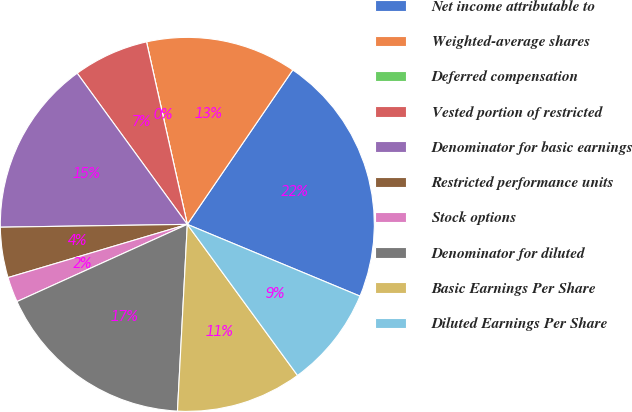Convert chart. <chart><loc_0><loc_0><loc_500><loc_500><pie_chart><fcel>Net income attributable to<fcel>Weighted-average shares<fcel>Deferred compensation<fcel>Vested portion of restricted<fcel>Denominator for basic earnings<fcel>Restricted performance units<fcel>Stock options<fcel>Denominator for diluted<fcel>Basic Earnings Per Share<fcel>Diluted Earnings Per Share<nl><fcel>21.73%<fcel>13.04%<fcel>0.0%<fcel>6.52%<fcel>15.22%<fcel>4.35%<fcel>2.18%<fcel>17.39%<fcel>10.87%<fcel>8.7%<nl></chart> 